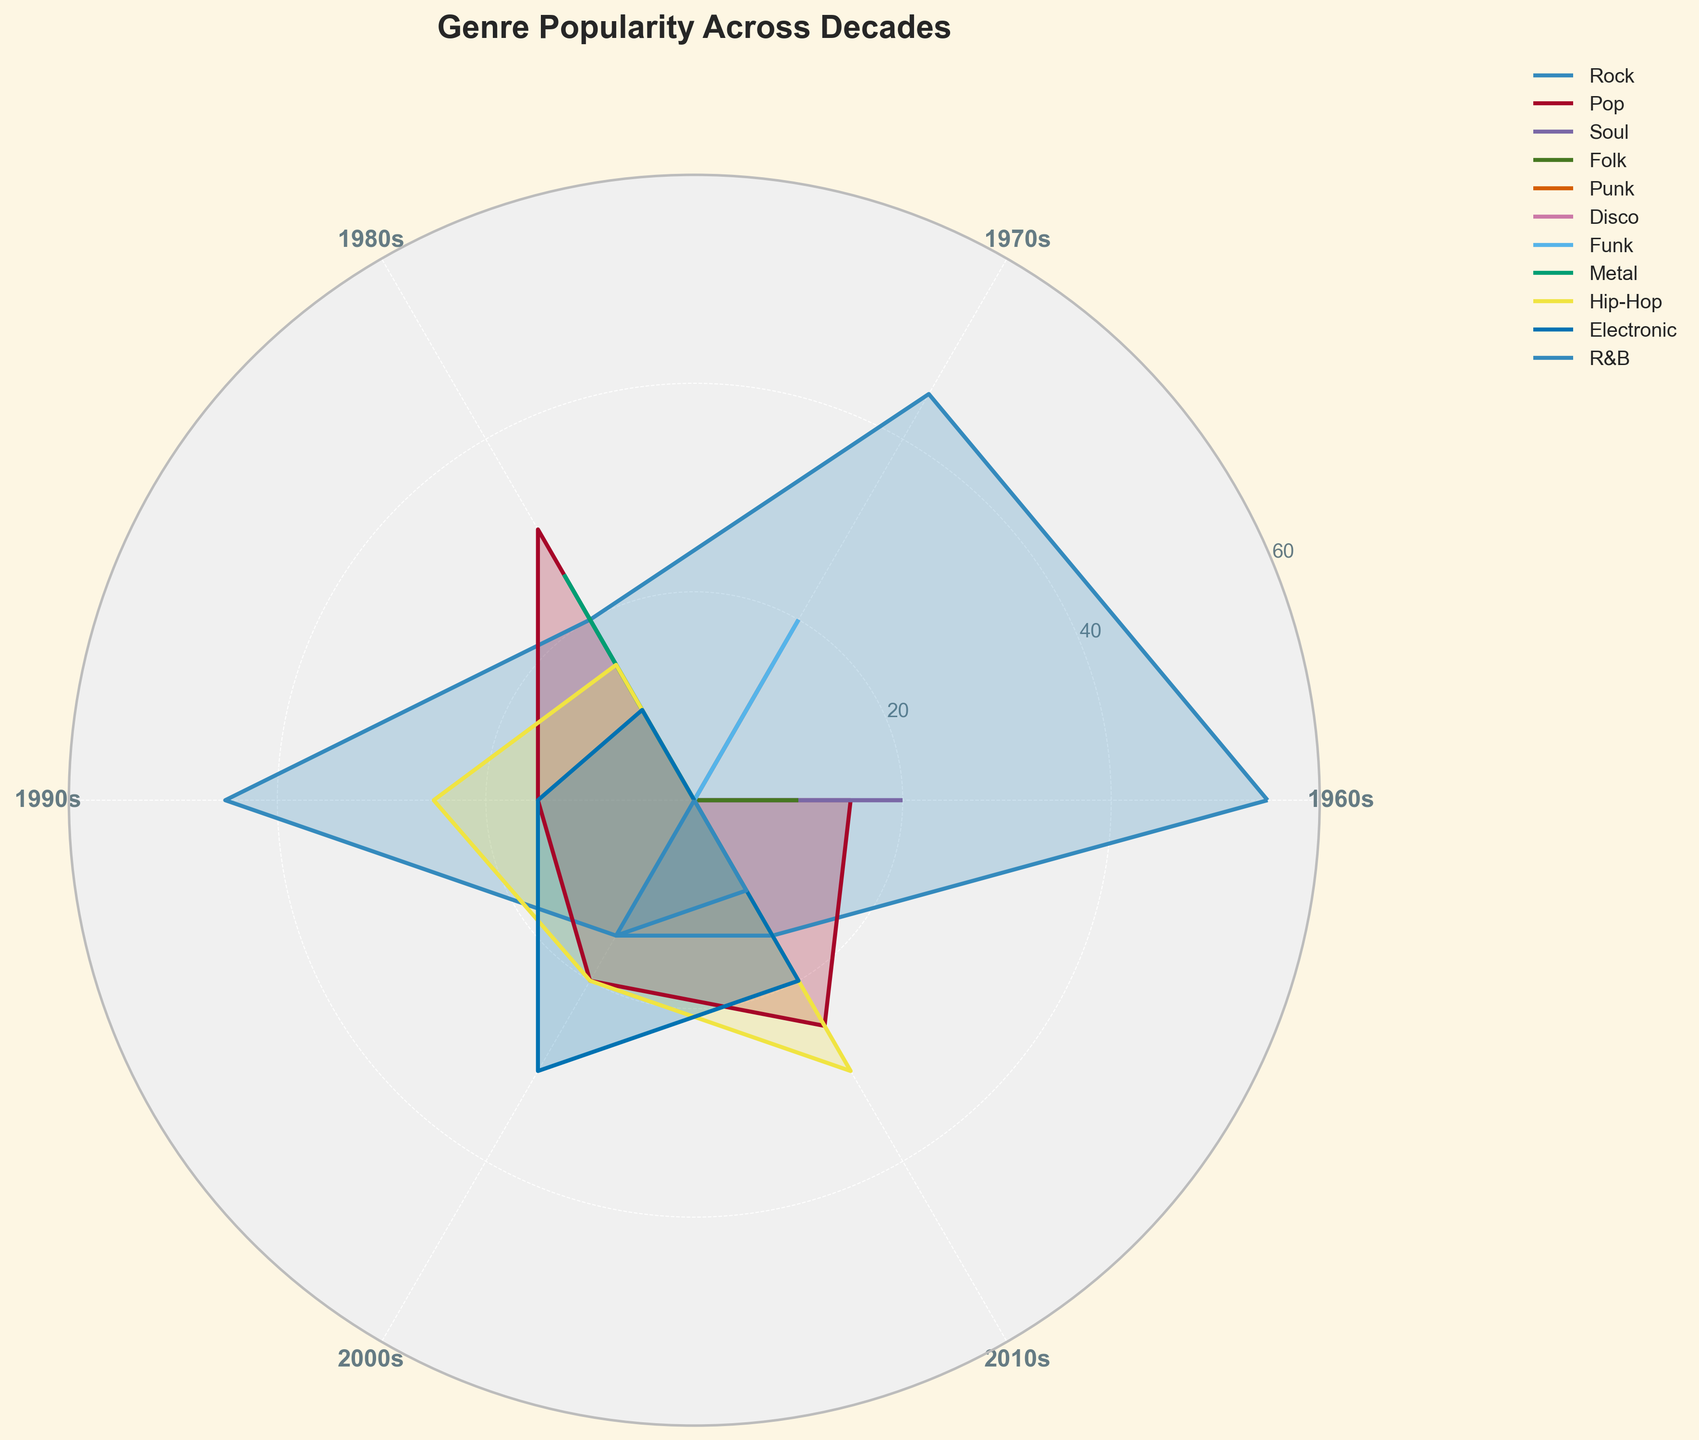Which decade has the highest popularity for Rock? To find the decade with the highest popularity for Rock, observe the height of the Rock plot on the chart for each decade. The 1970s exhibits the highest peak for Rock.
Answer: 1970s How does the popularity of Pop in the 1980s compare to the 2010s? Compare the heights of the Pop segments in the 1980s and 2010s. The plot shows a higher peak for Pop in the 1980s than in the 2010s.
Answer: 1980s > 2010s Which subgenres contribute to the popularity of Electronic music in the 2010s? To identify subgenres, look at the data columns about Electronic in the 2010s. The chart shows dubstep contributes to Electronic music's popularity in this decade.
Answer: Dubstep Is there any genre that maintains a consistent presence across all decades? Examine if any genre appears in every decade's segment on the chart. Rock is consistently present across all decades.
Answer: Rock What is the total popularity of Hip-Hop in the 2000s and 2010s combined? Add the Hip-Hop segments for the two decades. From the chart, Hip-Hop's popularity in the 2000s and 2010s are 20 and 30, respectively. The total is 20 + 30 = 50.
Answer: 50 What is the trend in the popularity of Electronic music from the 1990s to the 2010s? Observe the plot for Electronic from the 1990s, 2000s, and 2010s. The chart indicates an increasing trend, with popularity climbing from 15 to 30 to 20.
Answer: Increasing Which genre saw a significant rise in popularity from the 1960s to the 1980s? Compare the height of the plots for each genre over the 1960s and 1980s. Pop sees a notable rise, growing from a modest peak to substantial popularity.
Answer: Pop How does the popularity of Punk in the 1970s compare with the popularity of Hip-Hop in the same decade? Compare the heights of the plots for Punk and Hip-Hop in the 1970s. The chart shows that while Punk has a notable presence, Hip-Hop does not appear, indicating Punk's higher popularity.
Answer: Punk > Hip-Hop Which decade shows the most diverse range of genre popularity? Check the width of various genre plots in each decade. The 1970s display many genres with high popularity peaks, indicating a diverse musical landscape.
Answer: 1970s Is R&B more popular in the 2000s or 2010s, and by how much? Compare the heights of R&B in the 2000s and 2010s. The chart shows R&B at 15 in the 2000s and 10 in the 2010s, yielding a difference of 15 - 10 = 5.
Answer: 2000s by 5 